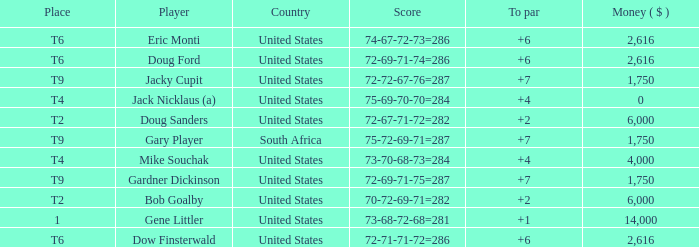What is the average To Par, when Score is "72-67-71-72=282"? 2.0. 